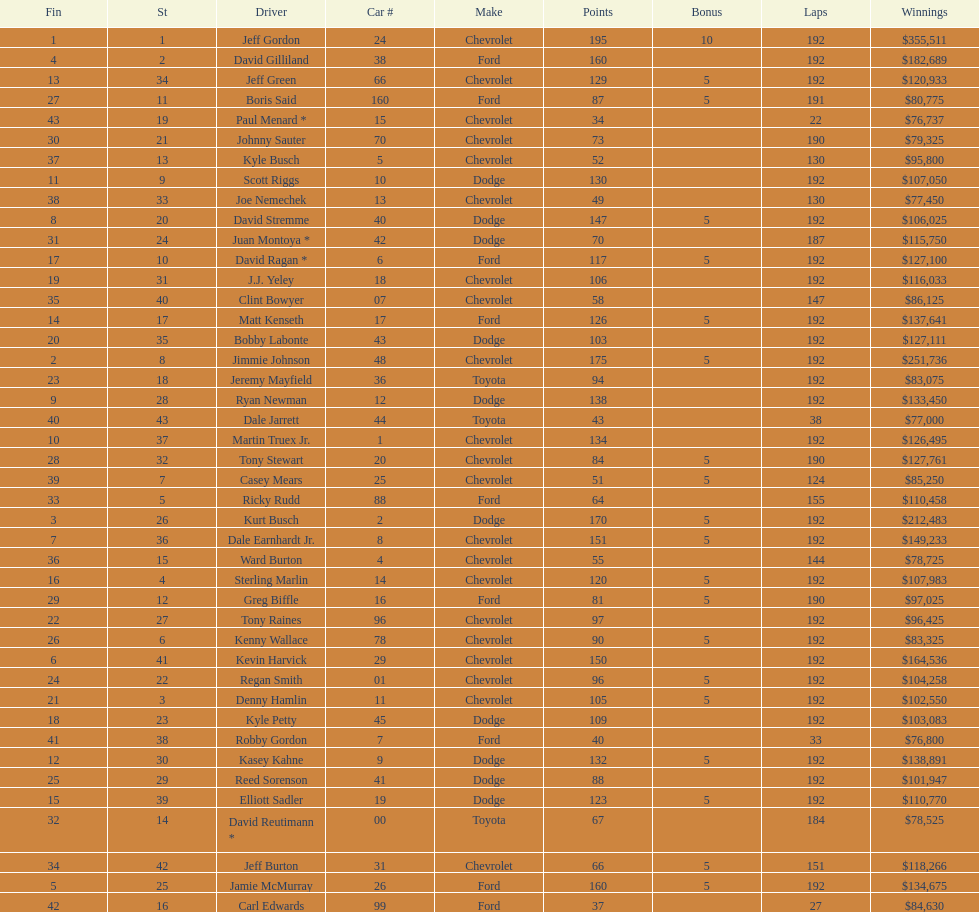Which make had the most consecutive finishes at the aarons 499? Chevrolet. 